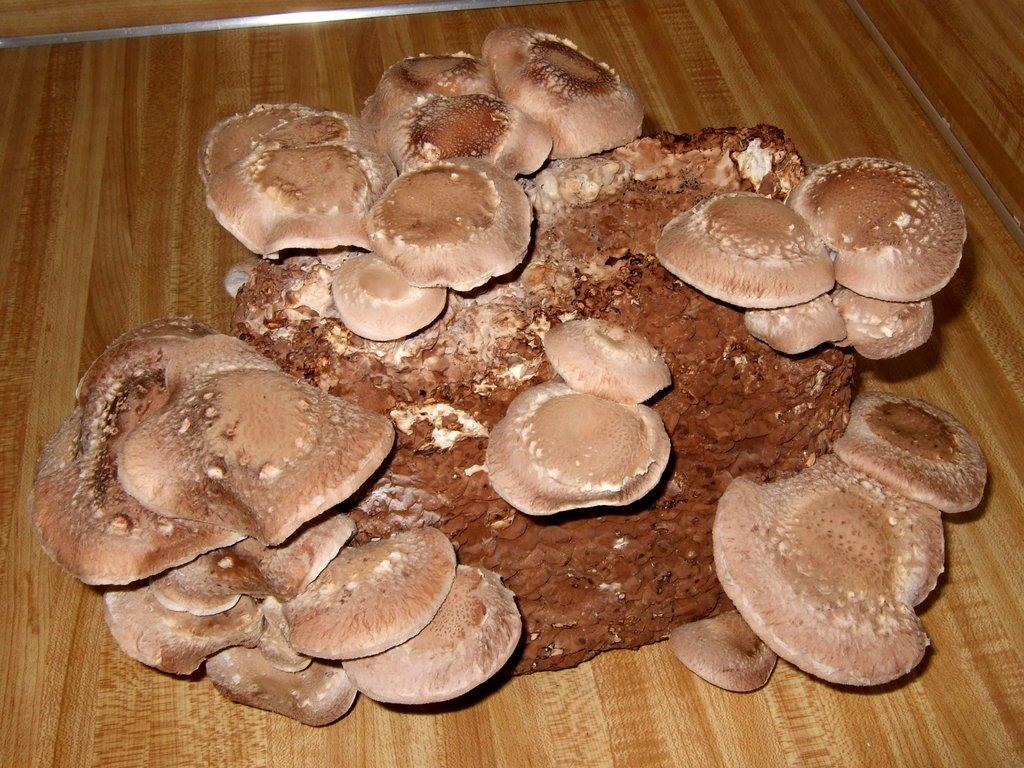What type of fungi can be seen in the image? There are mushrooms in the image. Where are the mushrooms located? The mushrooms are on a stone. What is the stone placed on in the image? The stone is on a table. What time is displayed on the clock in the image? There is no clock present in the image; it features mushrooms on a stone on a table. 